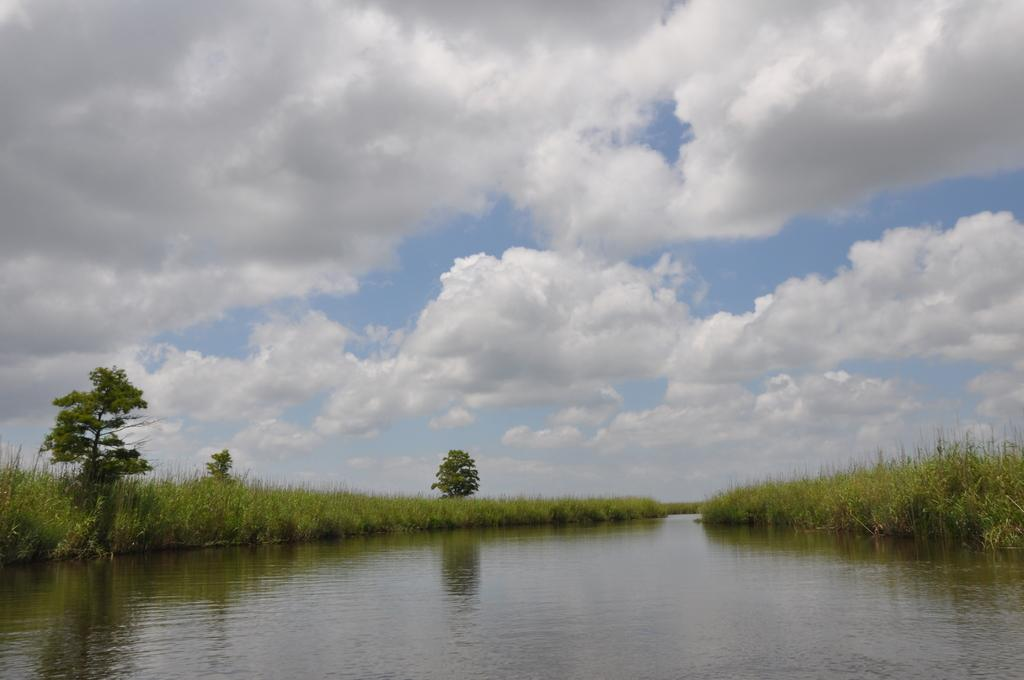What is the main feature of the image? There is a water body in the image. What can be seen on either side of the water body? There are plants and trees on either side of the water body. How would you describe the sky in the image? The sky is cloudy in the image. Can you see any celery growing near the water body in the image? There is no celery visible in the image. What type of tail can be seen on the trees in the image? There are no tails present in the image; it features a water body with plants and trees on either side. 